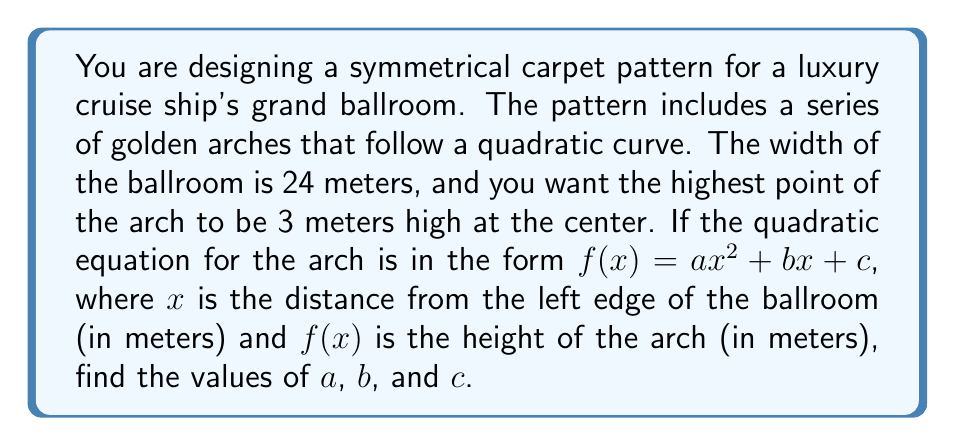Teach me how to tackle this problem. Let's approach this step-by-step:

1) We know that the arch is symmetrical and centered in the ballroom. This means the axis of symmetry is at $x = 12$ (half the width of the 24-meter ballroom).

2) We can use three points to determine the quadratic equation:
   - At $x = 0$, $f(0) = 0$ (left edge of the ballroom)
   - At $x = 12$, $f(12) = 3$ (center of the ballroom, highest point)
   - At $x = 24$, $f(24) = 0$ (right edge of the ballroom)

3) Using these points in the general form $f(x) = ax^2 + bx + c$:

   $0 = a(0)^2 + b(0) + c$, so $c = 0$
   $3 = a(12)^2 + b(12) + 0$
   $0 = a(24)^2 + b(24) + 0$

4) From the last equation:
   $0 = 576a + 24b$
   $b = -24a$

5) Substituting this into the second equation:
   $3 = 144a + 12(-24a)$
   $3 = 144a - 288a = -144a$
   $a = -\frac{3}{144} = -\frac{1}{48}$

6) Now we can find $b$:
   $b = -24(-\frac{1}{48}) = \frac{1}{2}$

7) We already know $c = 0$

Therefore, the quadratic equation is:

$$f(x) = -\frac{1}{48}x^2 + \frac{1}{2}x + 0$$
Answer: $a = -\frac{1}{48}$, $b = \frac{1}{2}$, $c = 0$ 